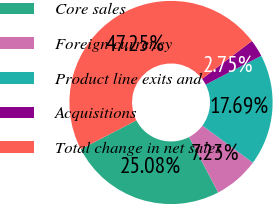<chart> <loc_0><loc_0><loc_500><loc_500><pie_chart><fcel>Core sales<fcel>Foreign currency<fcel>Product line exits and<fcel>Acquisitions<fcel>Total change in net sales<nl><fcel>25.08%<fcel>7.23%<fcel>17.69%<fcel>2.75%<fcel>47.25%<nl></chart> 